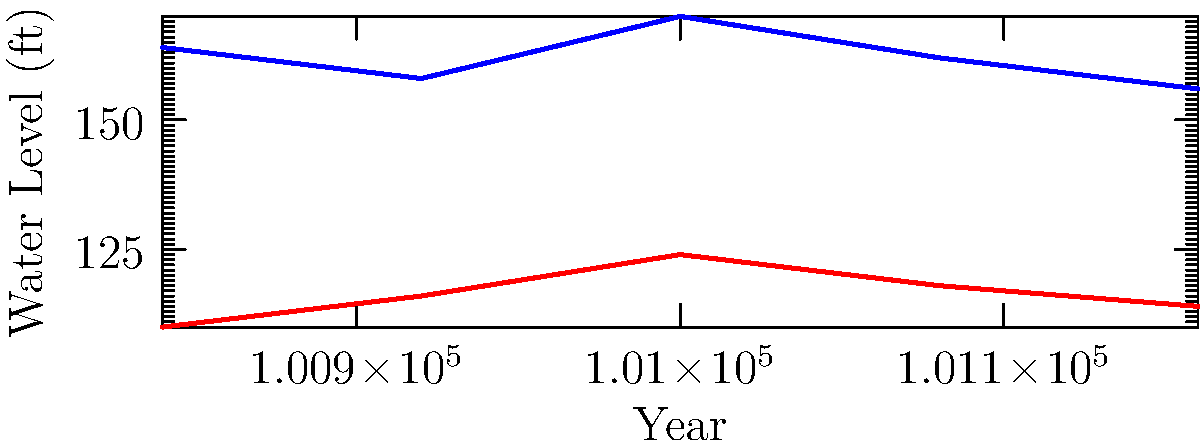According to the graph, in which year was the difference between the water levels of the Oostanaula and Etowah rivers the greatest? To find the year with the greatest difference in water levels between the Oostanaula and Etowah rivers, we need to:

1. Calculate the difference for each year:
   2018: 8.2 - 5.5 = 2.7 ft
   2019: 7.9 - 5.8 = 2.1 ft
   2020: 8.5 - 6.2 = 2.3 ft
   2021: 8.1 - 5.9 = 2.2 ft
   2022: 7.8 - 5.7 = 2.1 ft

2. Identify the largest difference:
   The largest difference is 2.7 ft, which occurred in 2018.

Therefore, the difference between the water levels of the Oostanaula and Etowah rivers was greatest in 2018.
Answer: 2018 